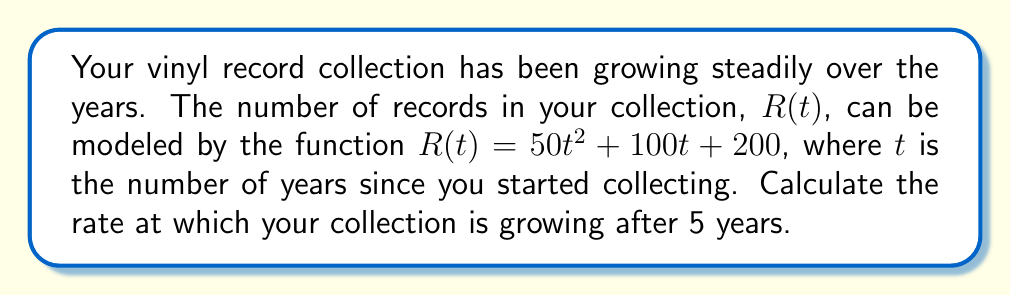Could you help me with this problem? To solve this problem, we need to find the derivative of the given function and evaluate it at $t = 5$. This will give us the instantaneous rate of change, or the rate at which the collection is growing after 5 years.

1. Given function: $R(t) = 50t^2 + 100t + 200$

2. To find the rate of change, we need to calculate $\frac{dR}{dt}$:
   $$\frac{dR}{dt} = \frac{d}{dt}(50t^2 + 100t + 200)$$

3. Using the power rule and constant rule of differentiation:
   $$\frac{dR}{dt} = 100t + 100$$

4. Now, we evaluate this derivative at $t = 5$:
   $$\frac{dR}{dt}\bigg|_{t=5} = 100(5) + 100 = 500 + 100 = 600$$

The rate of change at $t = 5$ is 600 records per year.
Answer: 600 records per year 